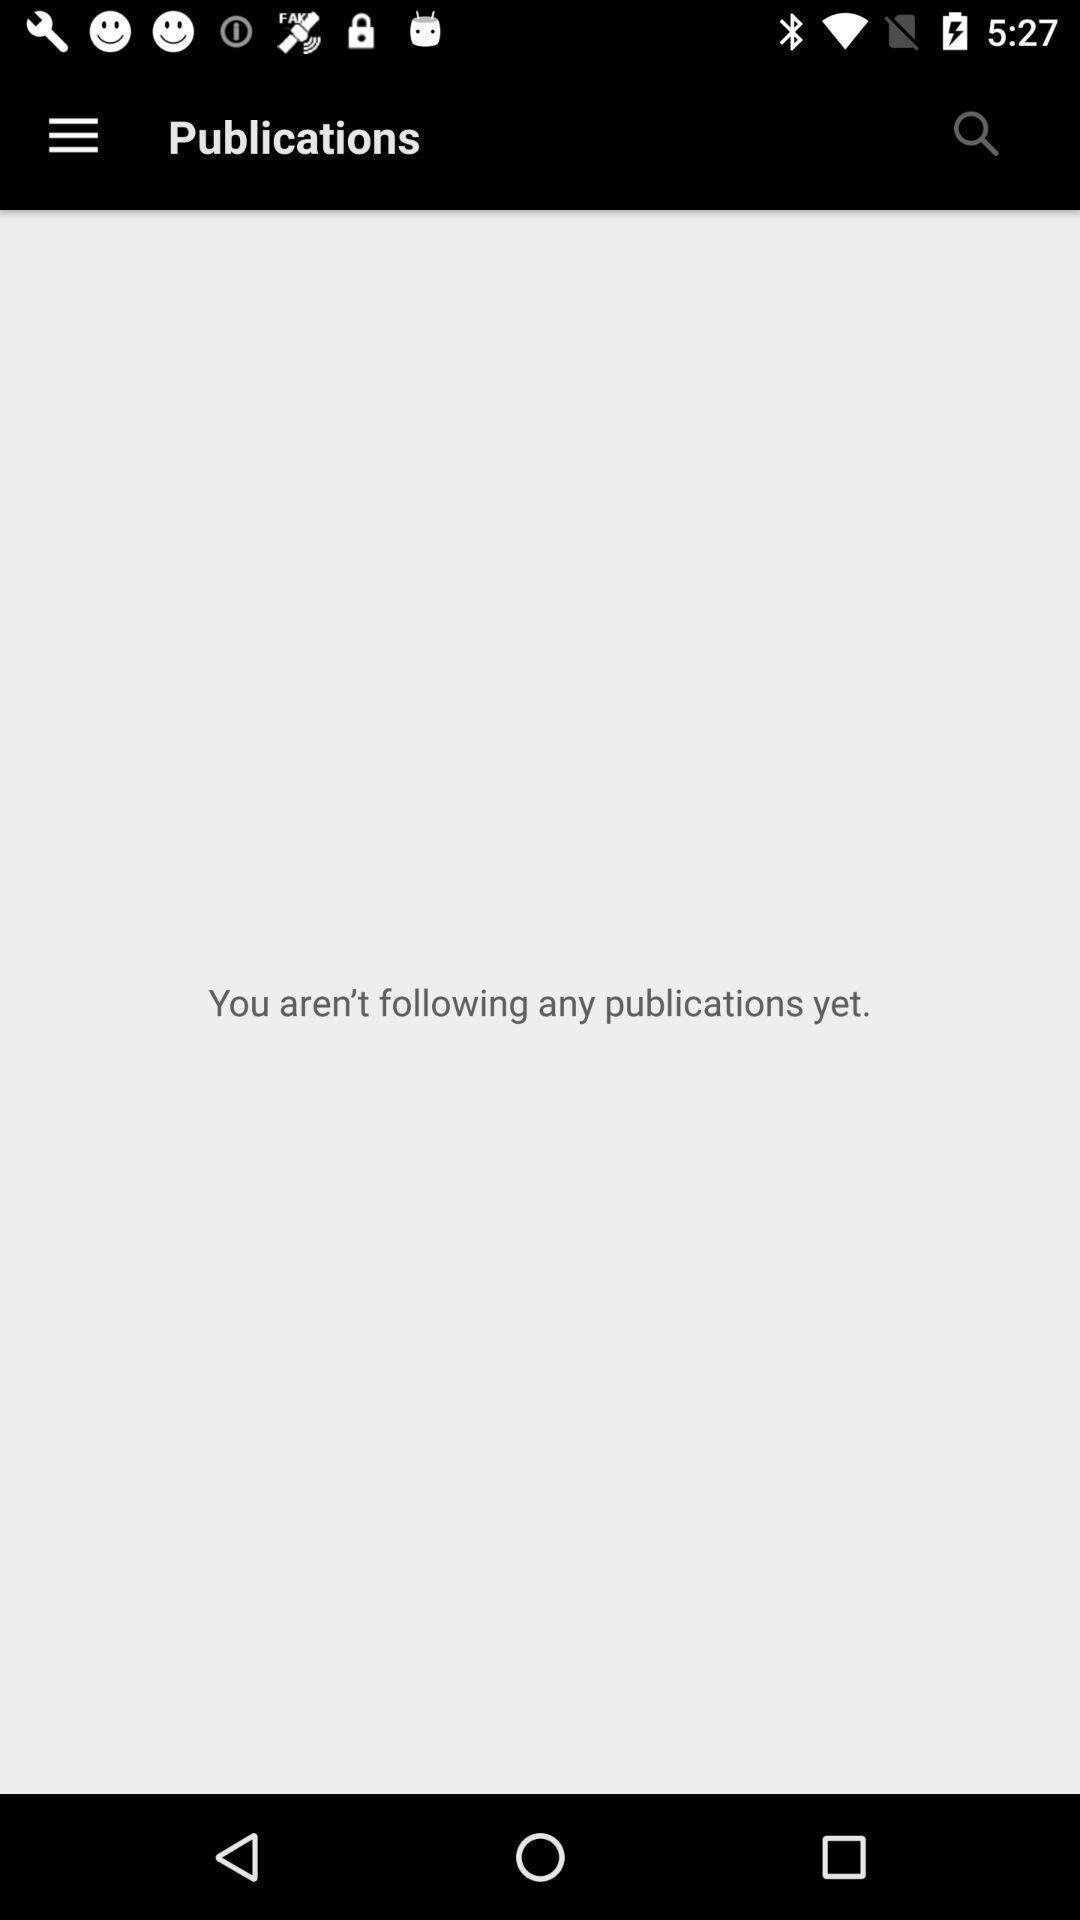Describe this image in words. Publications status showing in this page. 